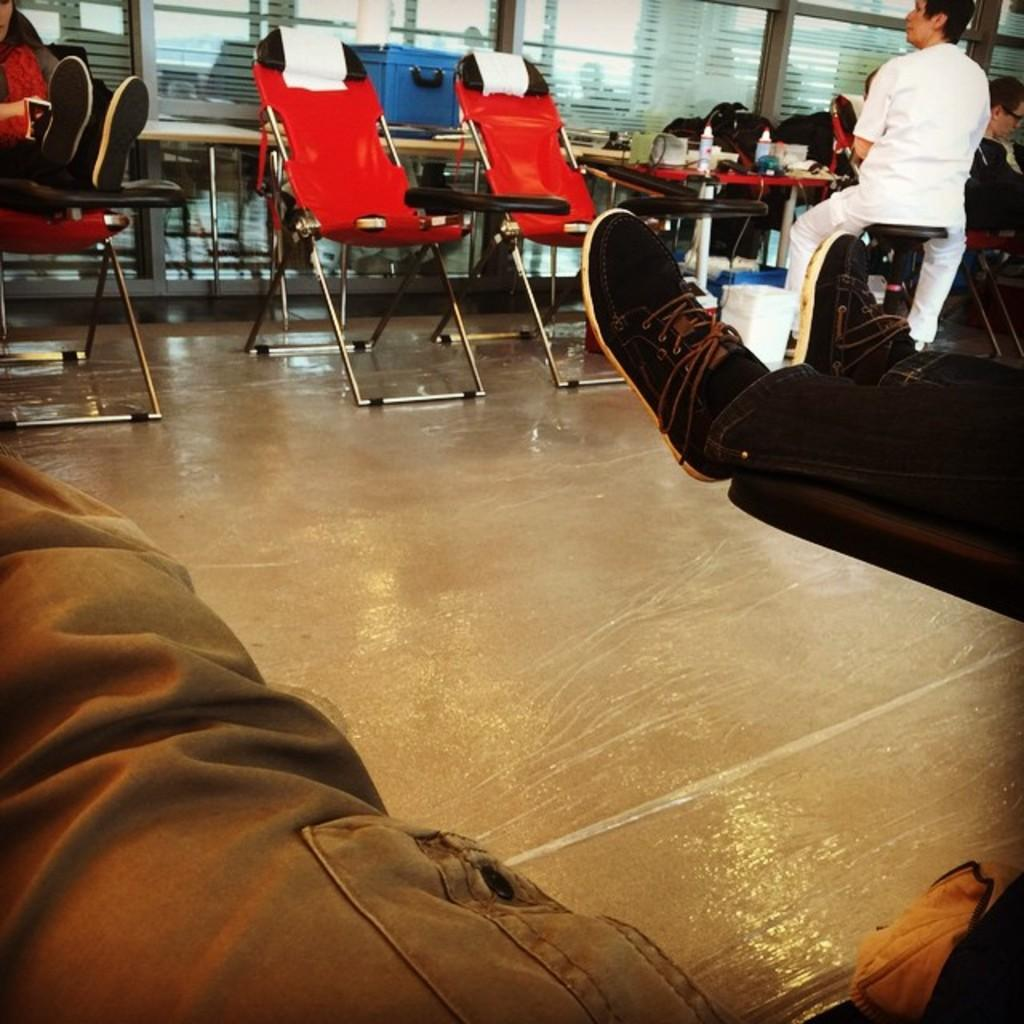What body parts can be seen in the image? There are persons' legs visible in the image. How many people are in the image? There are persons in the image. What type of furniture is present in the image? There are tables and chairs in the image. What architectural feature is visible in the image? There are windows in the image. What part of the room can be seen in the image? The floor is visible in the image. What type of ice can be seen melting on the floor in the image? There is no ice present in the image; only persons' legs, tables, chairs, windows, and the floor are visible. 